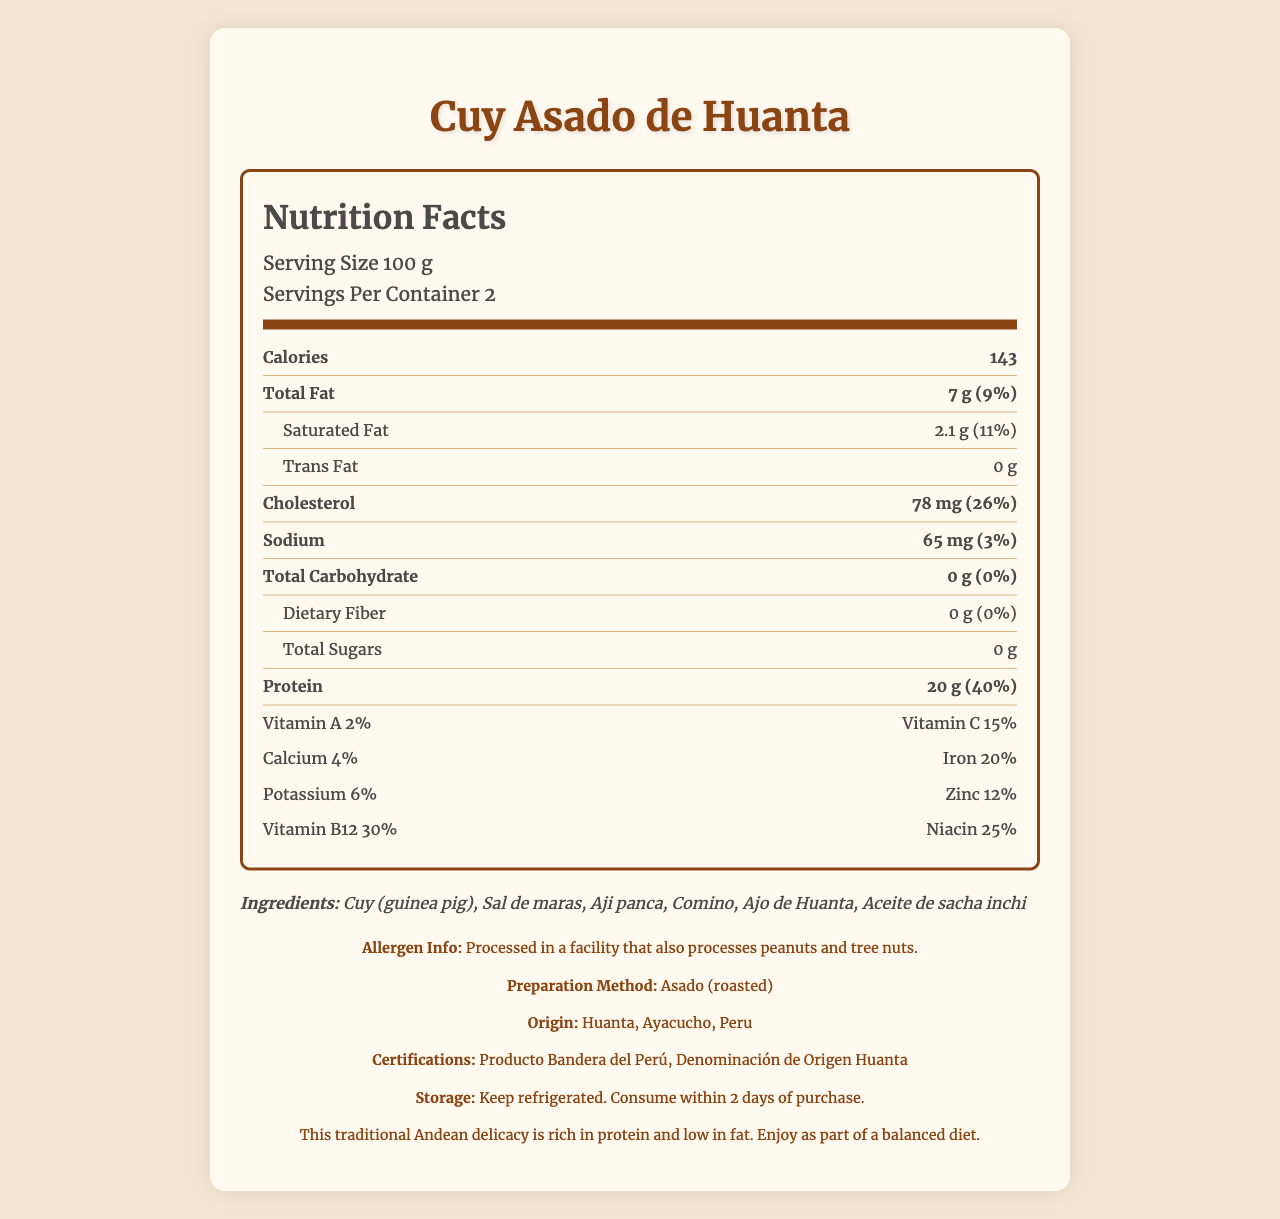what is the serving size? The serving size is explicitly stated as 100 g in the document under the nutrition label section.
Answer: 100 g how many servings are in the container? The document specifies that there are 2 servings per container in the serving information section.
Answer: 2 how many calories are in one serving? The number of calories per serving is clearly marked as 143 in the nutrition facts.
Answer: 143 how much protein is in one serving? The protein content per serving is listed as 20 g in the protein section of the nutrition label.
Answer: 20 g what is the percentage of daily value for saturated fat? The daily value percentage for saturated fat is indicated as 11%.
Answer: 11% which ingredient is not used in Cuy Asado de Huanta? A. Aji Amarillo B. Aji Panca C. Ajo de Huanta D. Comino The ingredients listed include Aji Panca, Ajo de Huanta, and Comino, but not Aji Amarillo.
Answer: A. Aji Amarillo what percentage of daily value for iron is provided? A. 4% B. 20% C. 6% The document states that the percentage of daily value for iron is 20%.
Answer: B. 20% is the product high in cholesterol? The product contains 78 mg of cholesterol, which accounts for 26% of the daily value. This is considered high.
Answer: Yes who can you infer is the intended audience for this product? Based on the certification ("Producto Bandera del Perú") and the detailed nutritional information, it targets general consumers who might be interested in traditional Peruvian foods and knowing the nutritional content.
Answer: General consumers looking for traditional Peruvian food with high protein content. how should the product be stored? The storage instructions clearly mention to keep the product refrigerated and consume it within 2 days of purchase.
Answer: Keep refrigerated. Consume within 2 days of purchase. how much total carbohydrate is in the product? The total carbohydrate content is listed as 0 g in the nutrition facts.
Answer: 0 g what certifications does the product have? The certifications listed for the product include "Producto Bandera del Perú" and "Denominación de Origen Huanta".
Answer: Producto Bandera del Perú, Denominación de Origen Huanta where is this product originally from? The origin of the product is stated as Huanta, Ayacucho, Peru.
Answer: Huanta, Ayacucho, Peru explain why Cuy Asado de Huanta might be considered a healthy choice. The high protein and low carbohydrate content, along with significant amounts of various vitamins and minerals, contribute to its perception as a healthy choice.
Answer: Cuy Asado de Huanta is considered healthy because it is rich in protein (20 g per serving, 40% daily value) and low in total carbohydrates (0 g). It also provides essential vitamins and minerals like Vitamin C (15% daily value), Iron (20% daily value), and Vitamin B12 (30% daily value). describe the overall nutritional profile of Cuy Asado de Huanta. The document provides comprehensive nutritional information that establishes the product as high in protein, nutrients, and low in carbohydrates, making it a healthy choice.
Answer: Cuy Asado de Huanta is a traditional Peruvian delicacy with a serving size of 100 g. Each serving contains 143 calories, 7 g of total fat (9% daily value), and 2.1 g of saturated fat (11% daily value). It has 0 g of trans fat and 78 mg of cholesterol (26% daily value). Sodium content is 65 mg (3% daily value). The product is particularly high in protein, with 20 g per serving (40% daily value). It provides vital nutrients including Vitamin A (2%), Vitamin C (15%), Calcium (4%), Iron (20%), Potassium (6%), Zinc (12%), Vitamin B12 (30%), and Niacin (25%). The ingredients include guinea pig, Sal de maras, Aji panca, Comino, Ajo de Huanta, and Aceite de sacha inchi. how many milligrams of potassium are in one serving? The document does not specify the exact milligrams of potassium, only the percentage daily value (6%).
Answer: Not enough information what are the primary allergens mentioned? The allergen information states that the product is processed in a facility that also processes peanuts and tree nuts.
Answer: Peanuts and tree nuts 